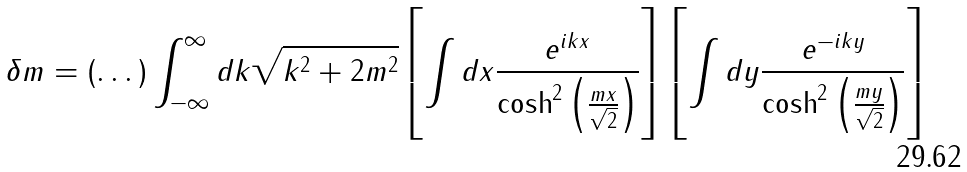<formula> <loc_0><loc_0><loc_500><loc_500>\delta m = ( \dots ) \int _ { - \infty } ^ { \infty } d k \sqrt { k ^ { 2 } + 2 m ^ { 2 } } \left [ \int d x \frac { e ^ { i k x } } { \cosh ^ { 2 } \left ( \frac { m x } { \sqrt { 2 } } \right ) } \right ] \left [ \int d y \frac { e ^ { - i k y } } { \cosh ^ { 2 } \left ( \frac { m y } { \sqrt { 2 } } \right ) } \right ]</formula> 